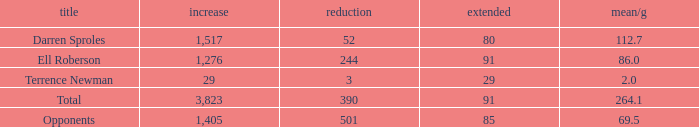What's the sum of all average yards gained when the gained yards is under 1,276 and lost more than 3 yards? None. 